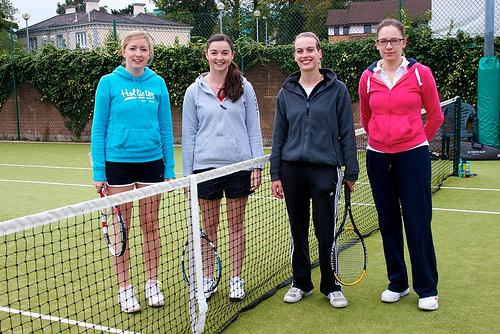Question: how many people are pictured?
Choices:
A. Three.
B. Two.
C. Five.
D. Four.
Answer with the letter. Answer: D Question: who does not have a tennis racket?
Choices:
A. My sister.
B. The girl in the pink jacket.
C. That duck.
D. Snow White.
Answer with the letter. Answer: B Question: where was this photo taken?
Choices:
A. On a soccer field.
B. On a basketball court.
C. On a baseball field.
D. On a tennis court.
Answer with the letter. Answer: D Question: why are there two players on a team?
Choices:
A. They are brothers.
B. They were chosen.
C. They are playing Doubles.
D. They like each other.
Answer with the letter. Answer: C Question: what game are they ready to play?
Choices:
A. Soccer.
B. Baseball.
C. Cricket.
D. Tennis.
Answer with the letter. Answer: D Question: what separates the two teams?
Choices:
A. The lines.
B. The rules.
C. The net.
D. The coaches.
Answer with the letter. Answer: C Question: what are three of the girls holding?
Choices:
A. Cups.
B. A pair of pants.
C. Some soup.
D. Tennis rackets.
Answer with the letter. Answer: D 